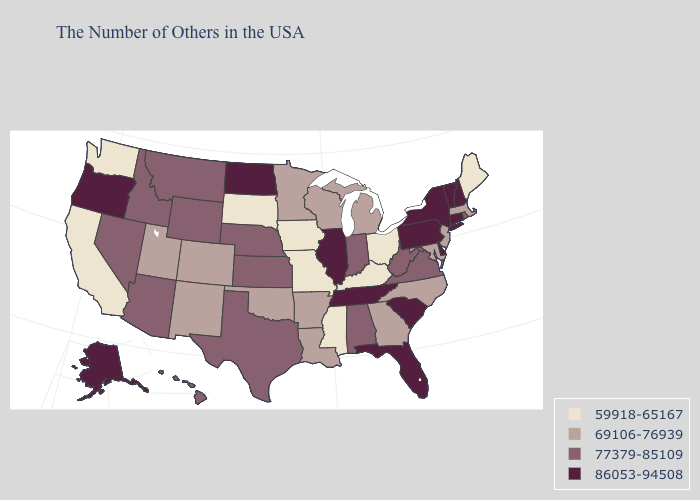Among the states that border Michigan , does Indiana have the highest value?
Keep it brief. Yes. Name the states that have a value in the range 59918-65167?
Be succinct. Maine, Ohio, Kentucky, Mississippi, Missouri, Iowa, South Dakota, California, Washington. What is the highest value in states that border Oklahoma?
Keep it brief. 77379-85109. Among the states that border Missouri , which have the lowest value?
Quick response, please. Kentucky, Iowa. Among the states that border Arkansas , does Tennessee have the highest value?
Concise answer only. Yes. Which states hav the highest value in the South?
Write a very short answer. Delaware, South Carolina, Florida, Tennessee. Does Arizona have a lower value than Alaska?
Write a very short answer. Yes. Is the legend a continuous bar?
Concise answer only. No. What is the value of Tennessee?
Keep it brief. 86053-94508. Name the states that have a value in the range 86053-94508?
Quick response, please. New Hampshire, Vermont, Connecticut, New York, Delaware, Pennsylvania, South Carolina, Florida, Tennessee, Illinois, North Dakota, Oregon, Alaska. Name the states that have a value in the range 59918-65167?
Concise answer only. Maine, Ohio, Kentucky, Mississippi, Missouri, Iowa, South Dakota, California, Washington. Among the states that border Georgia , which have the highest value?
Quick response, please. South Carolina, Florida, Tennessee. Does Maine have a lower value than Montana?
Keep it brief. Yes. How many symbols are there in the legend?
Short answer required. 4. What is the highest value in the USA?
Keep it brief. 86053-94508. 